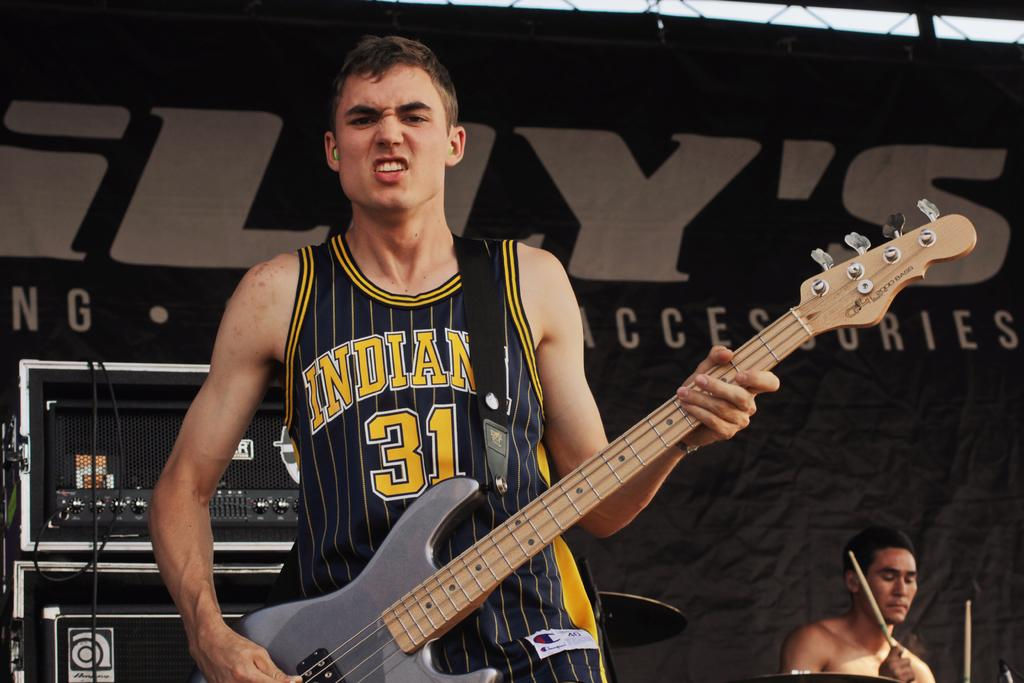<image>
Summarize the visual content of the image. Number 31 of Indiana is shown on the jersey of this guitar player. 